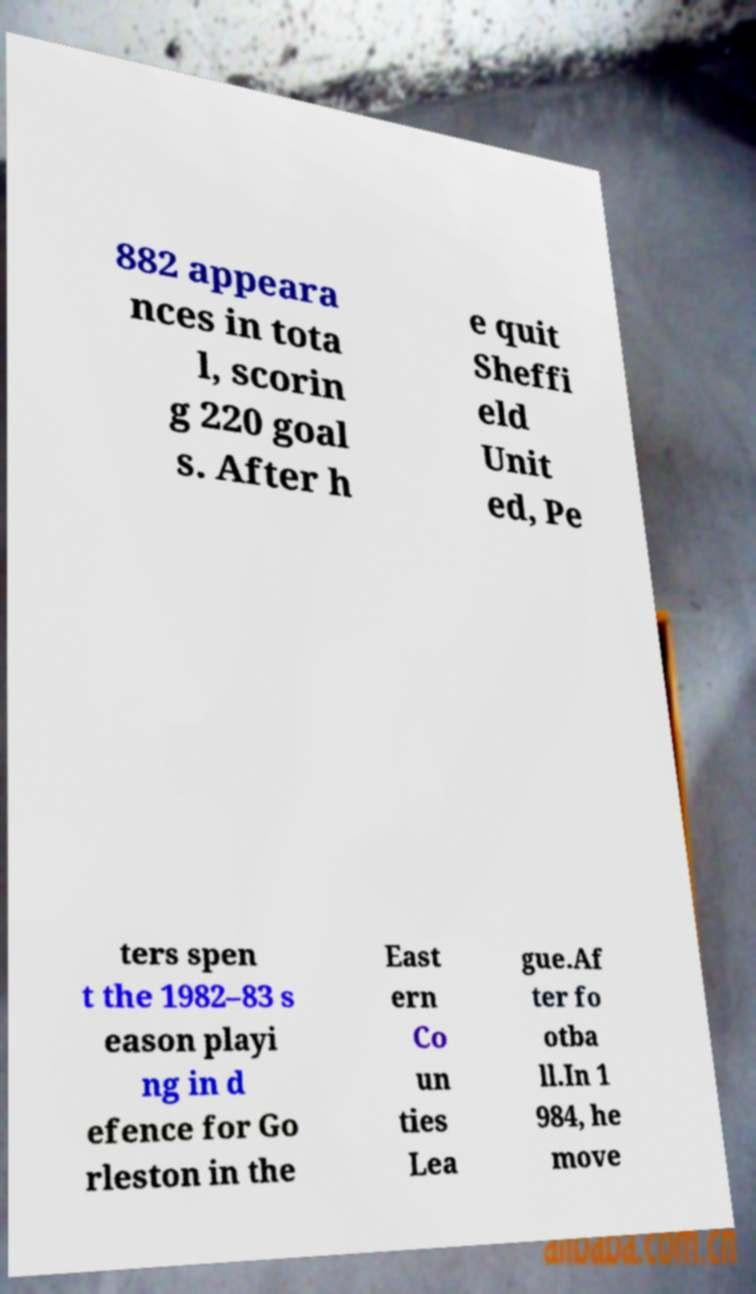Could you assist in decoding the text presented in this image and type it out clearly? 882 appeara nces in tota l, scorin g 220 goal s. After h e quit Sheffi eld Unit ed, Pe ters spen t the 1982–83 s eason playi ng in d efence for Go rleston in the East ern Co un ties Lea gue.Af ter fo otba ll.In 1 984, he move 